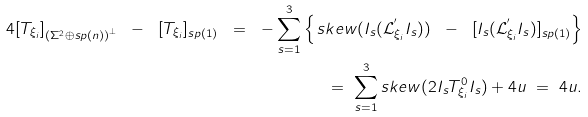Convert formula to latex. <formula><loc_0><loc_0><loc_500><loc_500>4 [ T _ { \xi _ { i } } ] _ { { ( \Sigma ^ { 2 } \oplus s p ( n ) ) } ^ { \perp } } \ - \ [ T _ { \xi _ { i } } ] _ { s p ( 1 ) } \ = \ - \sum _ { s = 1 } ^ { 3 } \left \{ \, s k e w ( I _ { s } ( \mathcal { L } ^ { ^ { \prime } } _ { \xi _ { i } } I _ { s } ) ) \ - \ [ I _ { s } ( \mathcal { L } ^ { ^ { \prime } } _ { \xi _ { i } } I _ { s } ) ] _ { s p ( 1 ) } \right \} \\ = \ \sum _ { s = 1 } ^ { 3 } s k e w ( 2 I _ { s } T ^ { 0 } _ { \xi _ { i } } I _ { s } ) + 4 u \ = \ 4 u .</formula> 